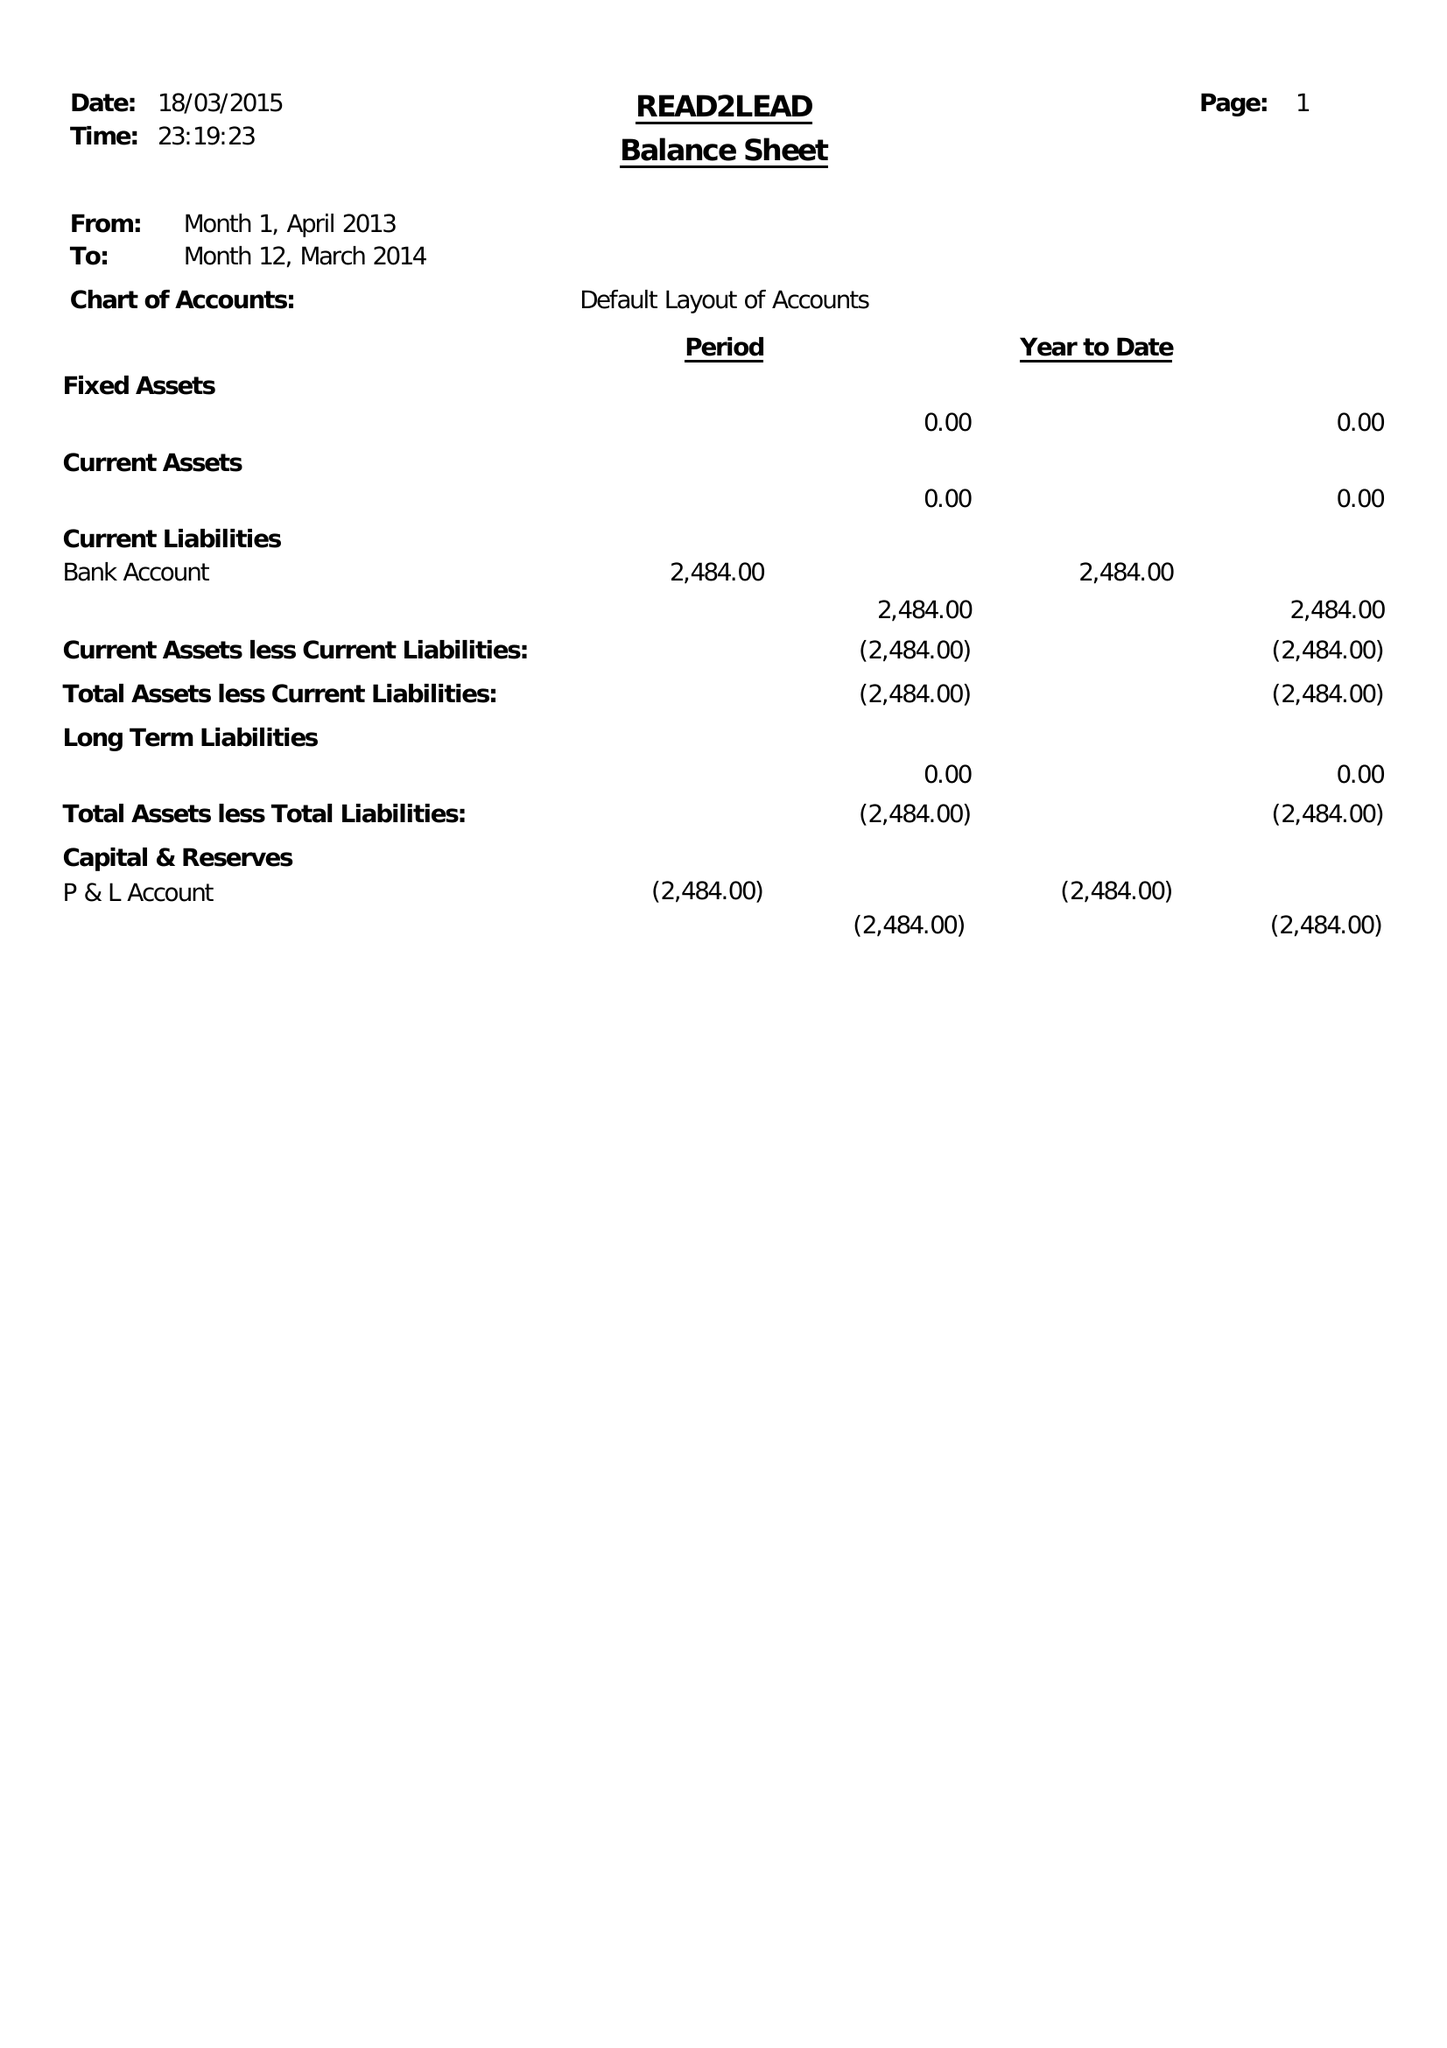What is the value for the address__street_line?
Answer the question using a single word or phrase. 43-45 WASHWOOD HEATH ROAD 